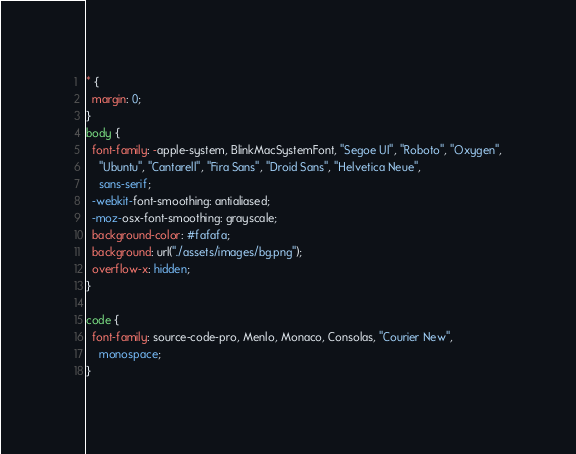<code> <loc_0><loc_0><loc_500><loc_500><_CSS_>* {
  margin: 0;
}
body {
  font-family: -apple-system, BlinkMacSystemFont, "Segoe UI", "Roboto", "Oxygen",
    "Ubuntu", "Cantarell", "Fira Sans", "Droid Sans", "Helvetica Neue",
    sans-serif;
  -webkit-font-smoothing: antialiased;
  -moz-osx-font-smoothing: grayscale;
  background-color: #fafafa;
  background: url("./assets/images/bg.png");
  overflow-x: hidden;
}

code {
  font-family: source-code-pro, Menlo, Monaco, Consolas, "Courier New",
    monospace;
}
</code> 